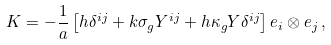Convert formula to latex. <formula><loc_0><loc_0><loc_500><loc_500>K = - \frac { 1 } { a } \left [ h \delta ^ { i j } + k \sigma _ { g } Y ^ { i j } + h \kappa _ { g } Y \delta ^ { i j } \right ] e _ { i } \otimes e _ { j } \, ,</formula> 